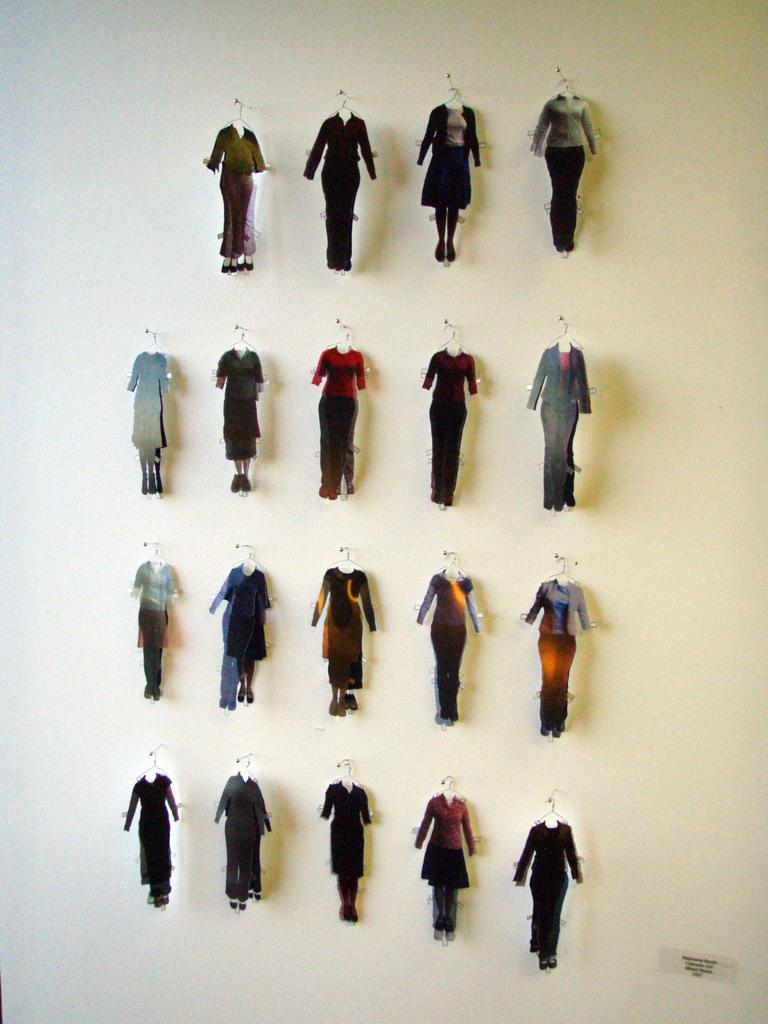What is in the foreground of the image? There are cardboard pieces in the shape of a human body in the foreground of the image. How are the cardboard pieces arranged or displayed? The cardboard pieces are hanging on pins on the wall. Can you see a snail moving across the cardboard pieces in the image? There is no snail present in the image, so it cannot be seen moving across the cardboard pieces. 